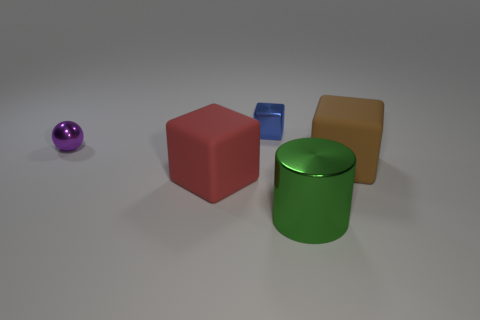Add 4 small red metal spheres. How many objects exist? 9 Subtract all large brown blocks. How many blocks are left? 2 Subtract 1 cubes. How many cubes are left? 2 Subtract all cyan cubes. Subtract all gray balls. How many cubes are left? 3 Subtract all cylinders. How many objects are left? 4 Add 5 blue shiny things. How many blue shiny things exist? 6 Subtract 0 gray cylinders. How many objects are left? 5 Subtract all big brown matte blocks. Subtract all purple balls. How many objects are left? 3 Add 5 blue cubes. How many blue cubes are left? 6 